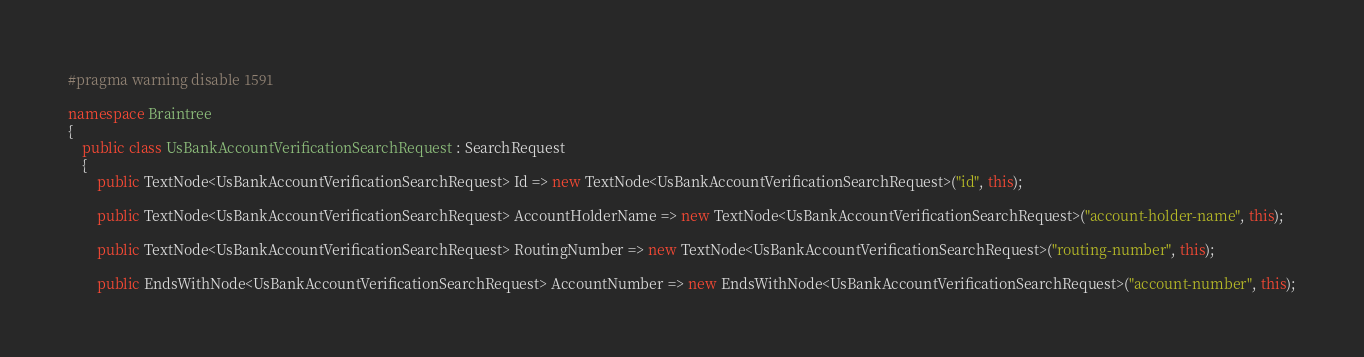Convert code to text. <code><loc_0><loc_0><loc_500><loc_500><_C#_>#pragma warning disable 1591

namespace Braintree
{
    public class UsBankAccountVerificationSearchRequest : SearchRequest
    {
        public TextNode<UsBankAccountVerificationSearchRequest> Id => new TextNode<UsBankAccountVerificationSearchRequest>("id", this);

        public TextNode<UsBankAccountVerificationSearchRequest> AccountHolderName => new TextNode<UsBankAccountVerificationSearchRequest>("account-holder-name", this);

        public TextNode<UsBankAccountVerificationSearchRequest> RoutingNumber => new TextNode<UsBankAccountVerificationSearchRequest>("routing-number", this);

        public EndsWithNode<UsBankAccountVerificationSearchRequest> AccountNumber => new EndsWithNode<UsBankAccountVerificationSearchRequest>("account-number", this);
</code> 